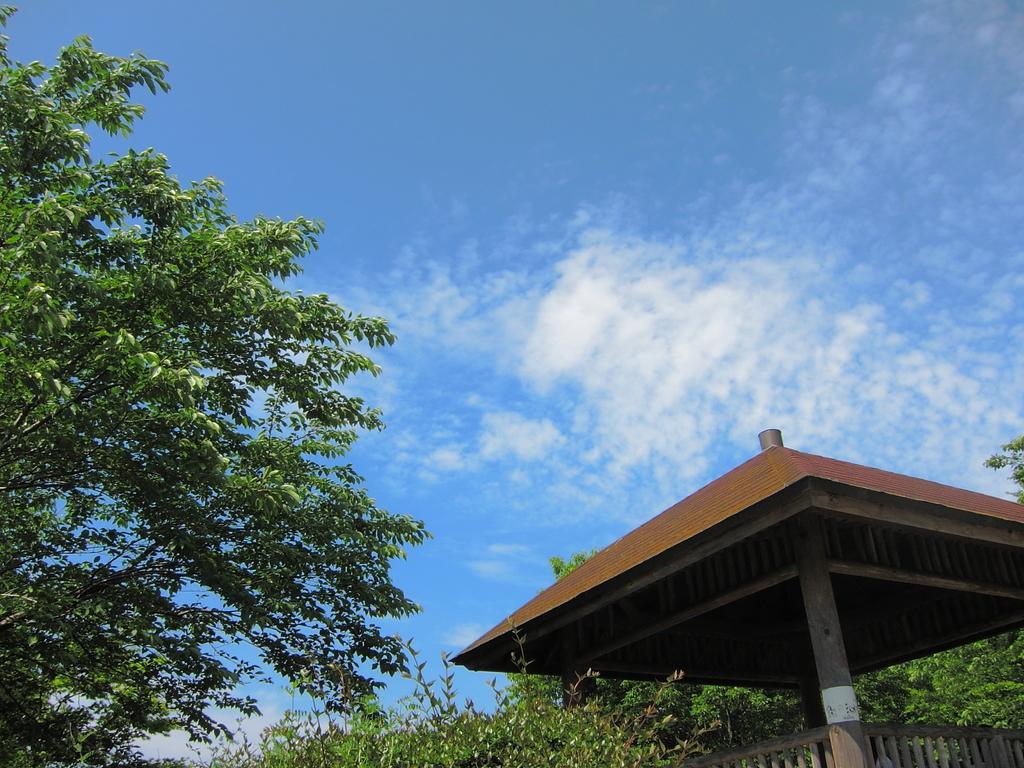Describe this image in one or two sentences. In this picture we can see trees, pillars, railing and roof top. In the background of the image we can see sky with clouds. 